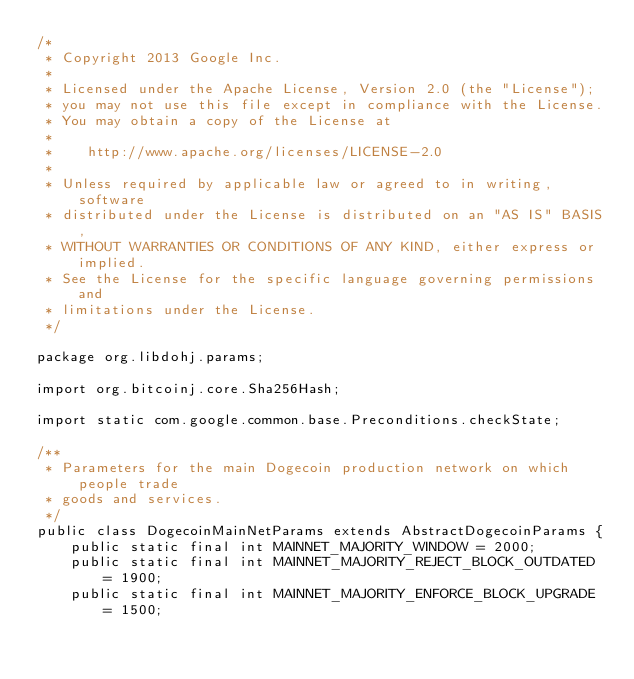Convert code to text. <code><loc_0><loc_0><loc_500><loc_500><_Java_>/*
 * Copyright 2013 Google Inc.
 *
 * Licensed under the Apache License, Version 2.0 (the "License");
 * you may not use this file except in compliance with the License.
 * You may obtain a copy of the License at
 *
 *    http://www.apache.org/licenses/LICENSE-2.0
 *
 * Unless required by applicable law or agreed to in writing, software
 * distributed under the License is distributed on an "AS IS" BASIS,
 * WITHOUT WARRANTIES OR CONDITIONS OF ANY KIND, either express or implied.
 * See the License for the specific language governing permissions and
 * limitations under the License.
 */

package org.libdohj.params;

import org.bitcoinj.core.Sha256Hash;

import static com.google.common.base.Preconditions.checkState;

/**
 * Parameters for the main Dogecoin production network on which people trade
 * goods and services.
 */
public class DogecoinMainNetParams extends AbstractDogecoinParams {
    public static final int MAINNET_MAJORITY_WINDOW = 2000;
    public static final int MAINNET_MAJORITY_REJECT_BLOCK_OUTDATED = 1900;
    public static final int MAINNET_MAJORITY_ENFORCE_BLOCK_UPGRADE = 1500;</code> 